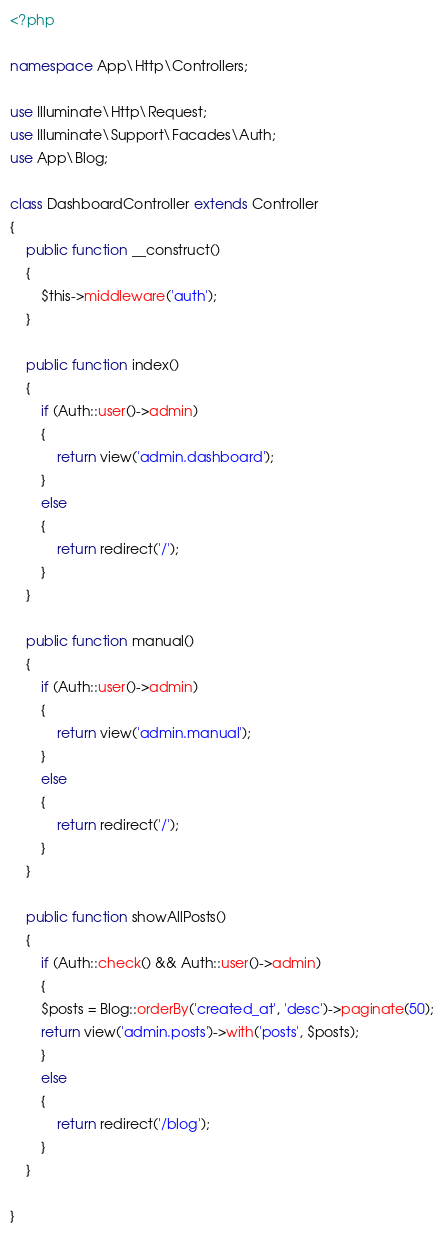Convert code to text. <code><loc_0><loc_0><loc_500><loc_500><_PHP_><?php

namespace App\Http\Controllers;

use Illuminate\Http\Request;
use Illuminate\Support\Facades\Auth;
use App\Blog;

class DashboardController extends Controller
{
    public function __construct()
    {
        $this->middleware('auth');
    }

    public function index()
    {
        if (Auth::user()->admin)
        {
            return view('admin.dashboard');
        }
        else 
        {
            return redirect('/');
        }
    }

    public function manual()
    {
        if (Auth::user()->admin)
        {
            return view('admin.manual');
        }
        else 
        {
            return redirect('/');
        }
    }

    public function showAllPosts()
    {
        if (Auth::check() && Auth::user()->admin)
        {
        $posts = Blog::orderBy('created_at', 'desc')->paginate(50);
        return view('admin.posts')->with('posts', $posts);
        }
        else 
        {
            return redirect('/blog');
        }
    }

}
</code> 